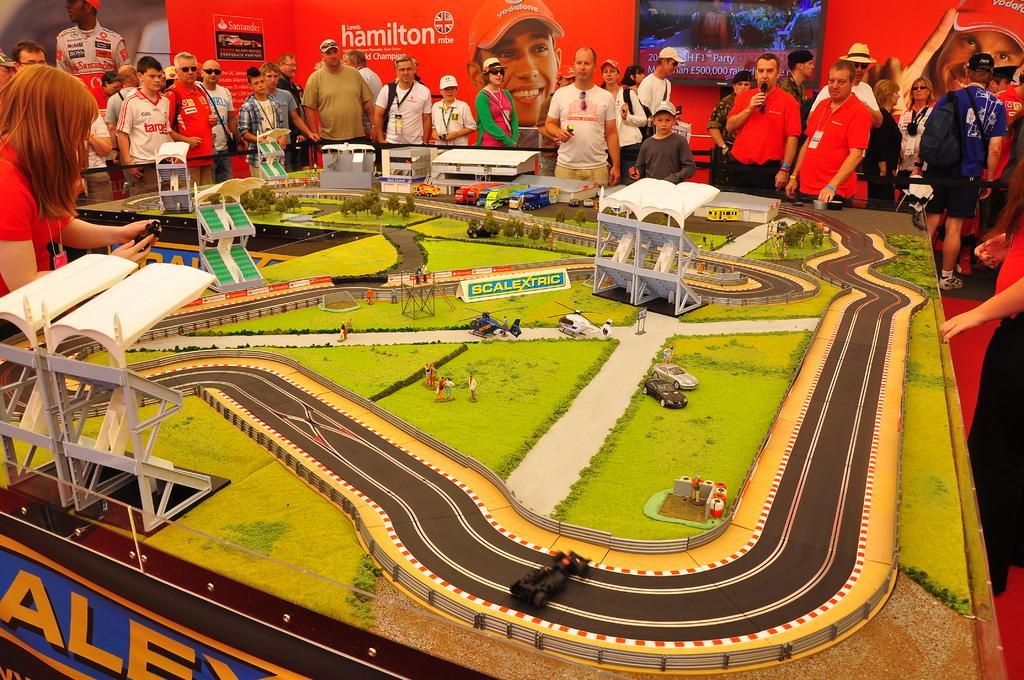In one or two sentences, can you explain what this image depicts? In the picture I can see a game board in which I can see toy vehicles, trees, the road and a few more things. Here I can see these people standing around the board. In the background, I can see the red color banner and I can see monitor fixed to the wall. 